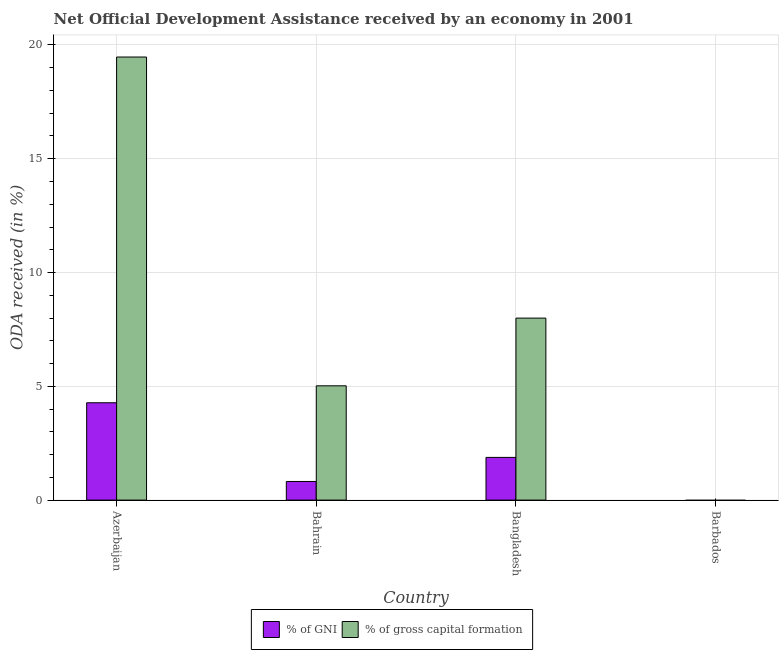Are the number of bars on each tick of the X-axis equal?
Your answer should be compact. No. How many bars are there on the 1st tick from the left?
Provide a short and direct response. 2. In how many cases, is the number of bars for a given country not equal to the number of legend labels?
Offer a very short reply. 1. What is the oda received as percentage of gni in Bangladesh?
Offer a terse response. 1.88. Across all countries, what is the maximum oda received as percentage of gni?
Your answer should be compact. 4.28. In which country was the oda received as percentage of gni maximum?
Ensure brevity in your answer.  Azerbaijan. What is the total oda received as percentage of gross capital formation in the graph?
Provide a short and direct response. 32.49. What is the difference between the oda received as percentage of gni in Bahrain and that in Bangladesh?
Ensure brevity in your answer.  -1.06. What is the difference between the oda received as percentage of gross capital formation in Bangladesh and the oda received as percentage of gni in Barbados?
Your answer should be very brief. 8. What is the average oda received as percentage of gni per country?
Your answer should be very brief. 1.74. What is the difference between the oda received as percentage of gross capital formation and oda received as percentage of gni in Bangladesh?
Offer a terse response. 6.12. Is the oda received as percentage of gni in Azerbaijan less than that in Bahrain?
Your answer should be very brief. No. Is the difference between the oda received as percentage of gross capital formation in Azerbaijan and Bangladesh greater than the difference between the oda received as percentage of gni in Azerbaijan and Bangladesh?
Ensure brevity in your answer.  Yes. What is the difference between the highest and the second highest oda received as percentage of gni?
Your answer should be very brief. 2.4. What is the difference between the highest and the lowest oda received as percentage of gross capital formation?
Provide a succinct answer. 19.47. What is the difference between two consecutive major ticks on the Y-axis?
Your answer should be very brief. 5. Are the values on the major ticks of Y-axis written in scientific E-notation?
Offer a very short reply. No. Does the graph contain any zero values?
Keep it short and to the point. Yes. Where does the legend appear in the graph?
Offer a terse response. Bottom center. How many legend labels are there?
Your answer should be very brief. 2. What is the title of the graph?
Offer a very short reply. Net Official Development Assistance received by an economy in 2001. What is the label or title of the X-axis?
Make the answer very short. Country. What is the label or title of the Y-axis?
Provide a short and direct response. ODA received (in %). What is the ODA received (in %) of % of GNI in Azerbaijan?
Your response must be concise. 4.28. What is the ODA received (in %) in % of gross capital formation in Azerbaijan?
Give a very brief answer. 19.47. What is the ODA received (in %) of % of GNI in Bahrain?
Your response must be concise. 0.82. What is the ODA received (in %) of % of gross capital formation in Bahrain?
Provide a short and direct response. 5.02. What is the ODA received (in %) of % of GNI in Bangladesh?
Give a very brief answer. 1.88. What is the ODA received (in %) in % of gross capital formation in Bangladesh?
Offer a terse response. 8. What is the ODA received (in %) in % of GNI in Barbados?
Offer a very short reply. 0. What is the ODA received (in %) of % of gross capital formation in Barbados?
Your answer should be compact. 0. Across all countries, what is the maximum ODA received (in %) in % of GNI?
Your answer should be compact. 4.28. Across all countries, what is the maximum ODA received (in %) of % of gross capital formation?
Your response must be concise. 19.47. Across all countries, what is the minimum ODA received (in %) in % of gross capital formation?
Provide a succinct answer. 0. What is the total ODA received (in %) of % of GNI in the graph?
Offer a very short reply. 6.97. What is the total ODA received (in %) in % of gross capital formation in the graph?
Your response must be concise. 32.49. What is the difference between the ODA received (in %) of % of GNI in Azerbaijan and that in Bahrain?
Your answer should be compact. 3.46. What is the difference between the ODA received (in %) in % of gross capital formation in Azerbaijan and that in Bahrain?
Provide a succinct answer. 14.45. What is the difference between the ODA received (in %) of % of GNI in Azerbaijan and that in Bangladesh?
Make the answer very short. 2.4. What is the difference between the ODA received (in %) of % of gross capital formation in Azerbaijan and that in Bangladesh?
Provide a succinct answer. 11.47. What is the difference between the ODA received (in %) of % of GNI in Bahrain and that in Bangladesh?
Provide a succinct answer. -1.06. What is the difference between the ODA received (in %) in % of gross capital formation in Bahrain and that in Bangladesh?
Keep it short and to the point. -2.98. What is the difference between the ODA received (in %) in % of GNI in Azerbaijan and the ODA received (in %) in % of gross capital formation in Bahrain?
Ensure brevity in your answer.  -0.74. What is the difference between the ODA received (in %) of % of GNI in Azerbaijan and the ODA received (in %) of % of gross capital formation in Bangladesh?
Provide a short and direct response. -3.72. What is the difference between the ODA received (in %) in % of GNI in Bahrain and the ODA received (in %) in % of gross capital formation in Bangladesh?
Your answer should be compact. -7.18. What is the average ODA received (in %) in % of GNI per country?
Your answer should be very brief. 1.74. What is the average ODA received (in %) of % of gross capital formation per country?
Keep it short and to the point. 8.12. What is the difference between the ODA received (in %) of % of GNI and ODA received (in %) of % of gross capital formation in Azerbaijan?
Make the answer very short. -15.19. What is the difference between the ODA received (in %) of % of GNI and ODA received (in %) of % of gross capital formation in Bahrain?
Provide a succinct answer. -4.2. What is the difference between the ODA received (in %) of % of GNI and ODA received (in %) of % of gross capital formation in Bangladesh?
Offer a terse response. -6.12. What is the ratio of the ODA received (in %) in % of GNI in Azerbaijan to that in Bahrain?
Provide a succinct answer. 5.23. What is the ratio of the ODA received (in %) of % of gross capital formation in Azerbaijan to that in Bahrain?
Make the answer very short. 3.88. What is the ratio of the ODA received (in %) of % of GNI in Azerbaijan to that in Bangladesh?
Make the answer very short. 2.28. What is the ratio of the ODA received (in %) of % of gross capital formation in Azerbaijan to that in Bangladesh?
Ensure brevity in your answer.  2.43. What is the ratio of the ODA received (in %) in % of GNI in Bahrain to that in Bangladesh?
Provide a short and direct response. 0.44. What is the ratio of the ODA received (in %) of % of gross capital formation in Bahrain to that in Bangladesh?
Offer a terse response. 0.63. What is the difference between the highest and the second highest ODA received (in %) of % of GNI?
Ensure brevity in your answer.  2.4. What is the difference between the highest and the second highest ODA received (in %) of % of gross capital formation?
Provide a succinct answer. 11.47. What is the difference between the highest and the lowest ODA received (in %) of % of GNI?
Offer a very short reply. 4.28. What is the difference between the highest and the lowest ODA received (in %) of % of gross capital formation?
Your response must be concise. 19.47. 